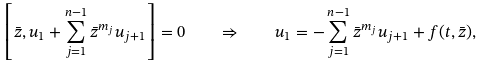<formula> <loc_0><loc_0><loc_500><loc_500>\left [ \bar { z } , u _ { 1 } + \sum _ { j = 1 } ^ { n - 1 } \bar { z } ^ { m _ { j } } u _ { j + 1 } \right ] = 0 \quad \Rightarrow \quad u _ { 1 } = - \sum _ { j = 1 } ^ { n - 1 } \bar { z } ^ { m _ { j } } u _ { j + 1 } + f ( t , \bar { z } ) ,</formula> 